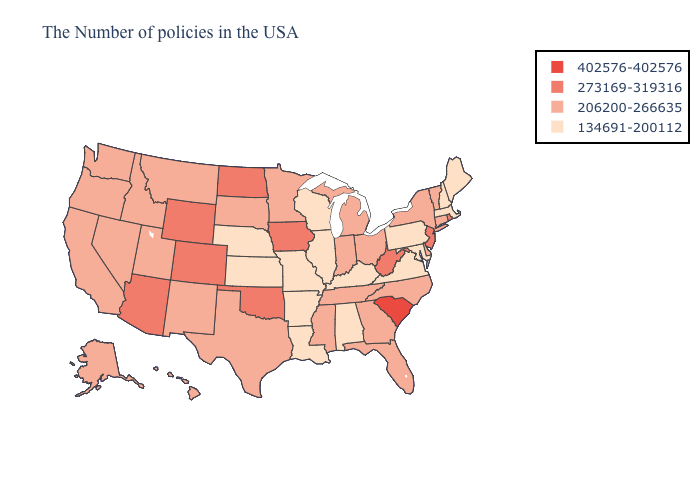Name the states that have a value in the range 273169-319316?
Answer briefly. Rhode Island, New Jersey, West Virginia, Iowa, Oklahoma, North Dakota, Wyoming, Colorado, Arizona. What is the lowest value in states that border New York?
Write a very short answer. 134691-200112. What is the value of Michigan?
Be succinct. 206200-266635. Name the states that have a value in the range 206200-266635?
Give a very brief answer. Vermont, Connecticut, New York, Delaware, North Carolina, Ohio, Florida, Georgia, Michigan, Indiana, Tennessee, Mississippi, Minnesota, Texas, South Dakota, New Mexico, Utah, Montana, Idaho, Nevada, California, Washington, Oregon, Alaska, Hawaii. Name the states that have a value in the range 134691-200112?
Quick response, please. Maine, Massachusetts, New Hampshire, Maryland, Pennsylvania, Virginia, Kentucky, Alabama, Wisconsin, Illinois, Louisiana, Missouri, Arkansas, Kansas, Nebraska. Which states hav the highest value in the MidWest?
Quick response, please. Iowa, North Dakota. Does Michigan have the lowest value in the MidWest?
Keep it brief. No. Name the states that have a value in the range 402576-402576?
Quick response, please. South Carolina. Which states hav the highest value in the Northeast?
Write a very short answer. Rhode Island, New Jersey. Name the states that have a value in the range 134691-200112?
Give a very brief answer. Maine, Massachusetts, New Hampshire, Maryland, Pennsylvania, Virginia, Kentucky, Alabama, Wisconsin, Illinois, Louisiana, Missouri, Arkansas, Kansas, Nebraska. Name the states that have a value in the range 402576-402576?
Answer briefly. South Carolina. What is the lowest value in states that border North Dakota?
Quick response, please. 206200-266635. What is the value of New Jersey?
Give a very brief answer. 273169-319316. Does Colorado have a higher value than Oklahoma?
Quick response, please. No. Does the map have missing data?
Concise answer only. No. 